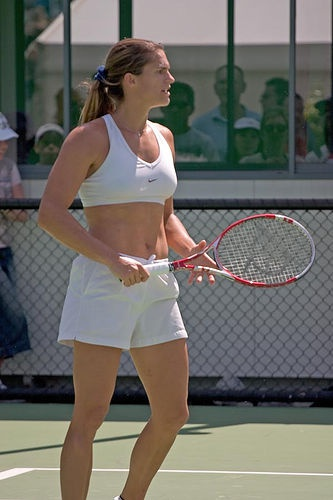Describe the objects in this image and their specific colors. I can see people in black, brown, and gray tones, tennis racket in black, gray, darkgray, brown, and lightgray tones, people in black, gray, and darkblue tones, people in black, teal, gray, and darkgreen tones, and people in black, teal, darkgreen, and gray tones in this image. 